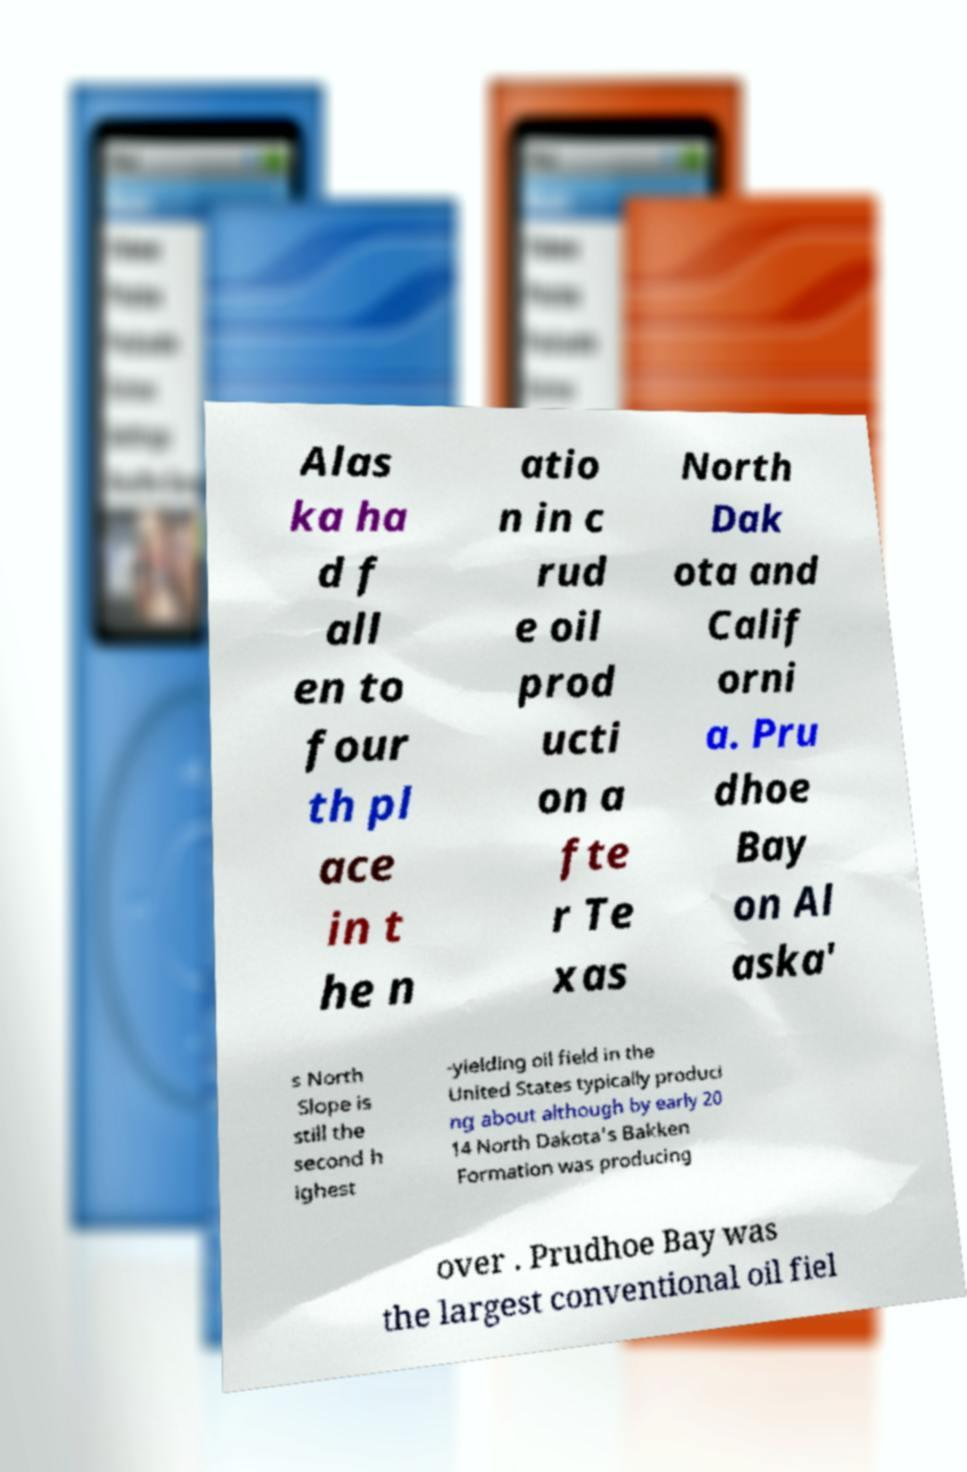Can you accurately transcribe the text from the provided image for me? Alas ka ha d f all en to four th pl ace in t he n atio n in c rud e oil prod ucti on a fte r Te xas North Dak ota and Calif orni a. Pru dhoe Bay on Al aska' s North Slope is still the second h ighest -yielding oil field in the United States typically produci ng about although by early 20 14 North Dakota's Bakken Formation was producing over . Prudhoe Bay was the largest conventional oil fiel 